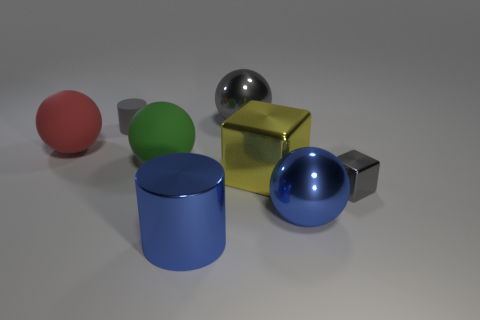What could be the possible sizes of these objects in real life? Without a common point of reference it's difficult to ascertain their exact sizes, but they might be sized like household objects. The cube could be akin to a small box, and the spheres and cylinders might be comparable to standard balls or cups in size. 